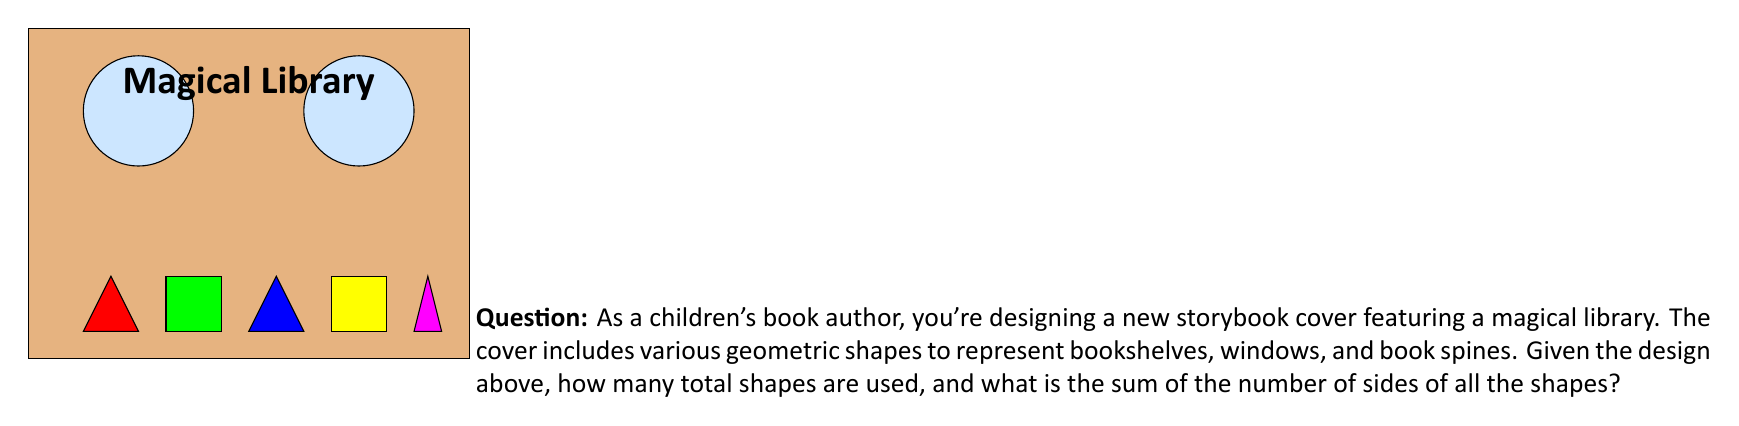Can you answer this question? Let's break this down step-by-step:

1) First, let's identify and count the shapes:
   - 1 large rectangle (bookshelf)
   - 2 circles (windows)
   - 3 triangles (book spines)
   - 2 rectangles (book spines)

   Total number of shapes: $1 + 2 + 3 + 2 = 8$

2) Now, let's count the sides of each shape:
   - Rectangle: 4 sides
   - Circle: In geometry, a circle is considered to have infinite sides, but for this problem, we'll count it as 1 side (the circumference)
   - Triangle: 3 sides

3) Let's calculate the sum of sides:
   - Large rectangle: $4$ sides
   - 2 circles: $2 \times 1 = 2$ sides
   - 3 triangles: $3 \times 3 = 9$ sides
   - 2 small rectangles: $2 \times 4 = 8$ sides

4) Sum up all the sides:
   $$ 4 + 2 + 9 + 8 = 23 $$

Therefore, there are 8 total shapes, and the sum of the number of sides of all shapes is 23.
Answer: 8 shapes, 23 sides 